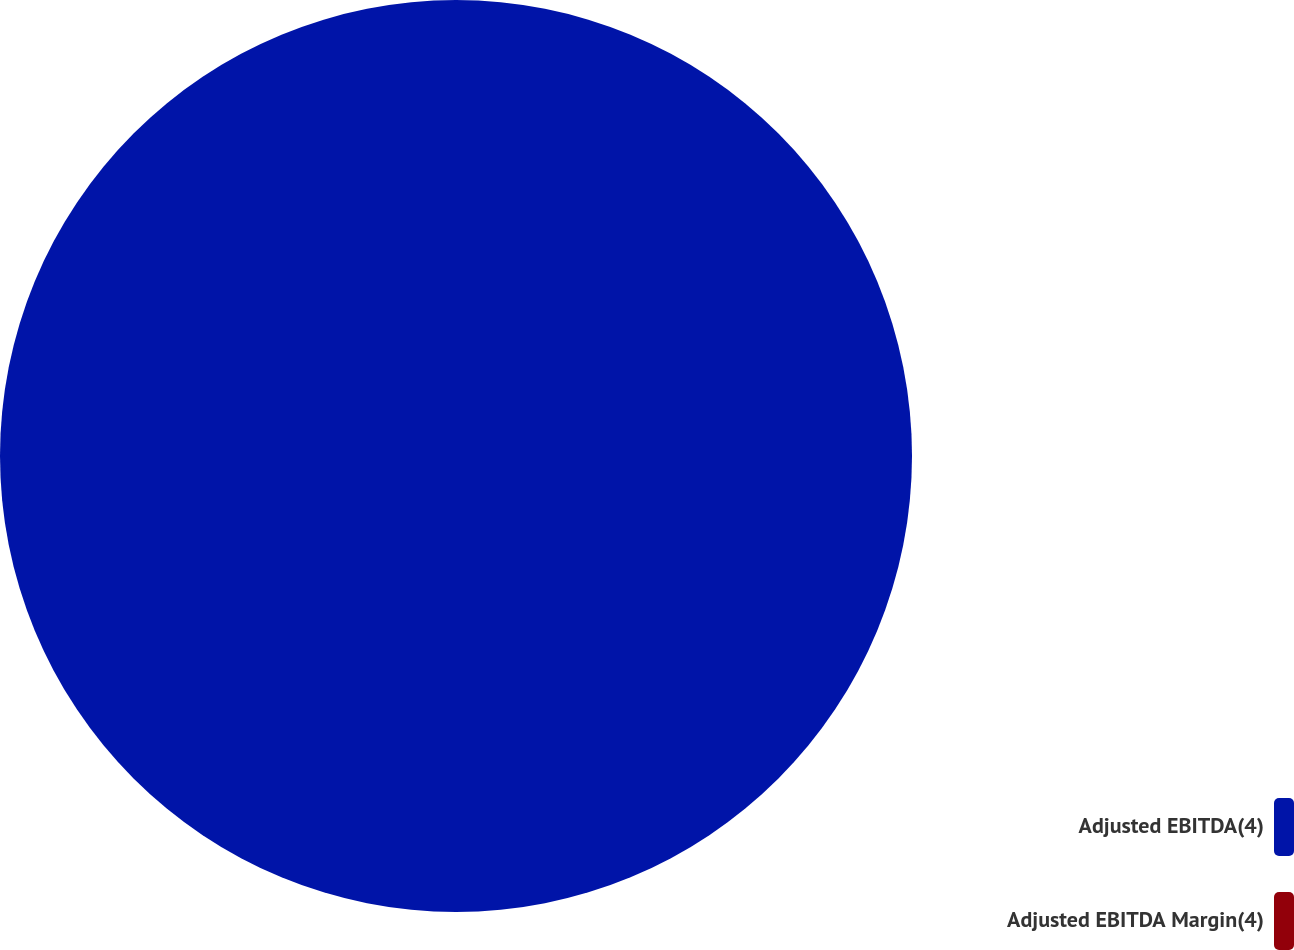<chart> <loc_0><loc_0><loc_500><loc_500><pie_chart><fcel>Adjusted EBITDA(4)<fcel>Adjusted EBITDA Margin(4)<nl><fcel>100.0%<fcel>0.0%<nl></chart> 